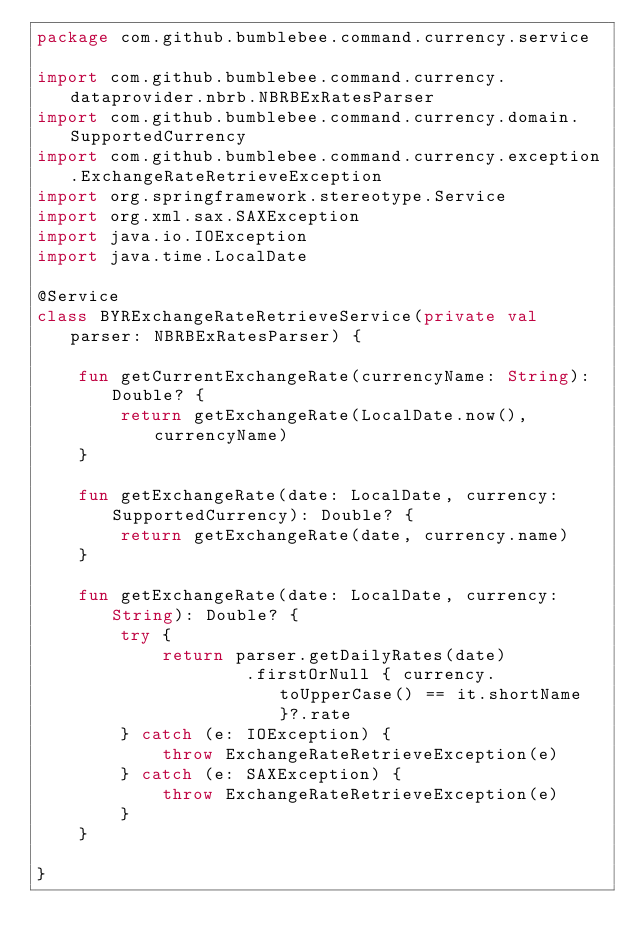<code> <loc_0><loc_0><loc_500><loc_500><_Kotlin_>package com.github.bumblebee.command.currency.service

import com.github.bumblebee.command.currency.dataprovider.nbrb.NBRBExRatesParser
import com.github.bumblebee.command.currency.domain.SupportedCurrency
import com.github.bumblebee.command.currency.exception.ExchangeRateRetrieveException
import org.springframework.stereotype.Service
import org.xml.sax.SAXException
import java.io.IOException
import java.time.LocalDate

@Service
class BYRExchangeRateRetrieveService(private val parser: NBRBExRatesParser) {

    fun getCurrentExchangeRate(currencyName: String): Double? {
        return getExchangeRate(LocalDate.now(), currencyName)
    }

    fun getExchangeRate(date: LocalDate, currency: SupportedCurrency): Double? {
        return getExchangeRate(date, currency.name)
    }

    fun getExchangeRate(date: LocalDate, currency: String): Double? {
        try {
            return parser.getDailyRates(date)
                    .firstOrNull { currency.toUpperCase() == it.shortName }?.rate
        } catch (e: IOException) {
            throw ExchangeRateRetrieveException(e)
        } catch (e: SAXException) {
            throw ExchangeRateRetrieveException(e)
        }
    }

}
</code> 